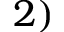Convert formula to latex. <formula><loc_0><loc_0><loc_500><loc_500>2 )</formula> 